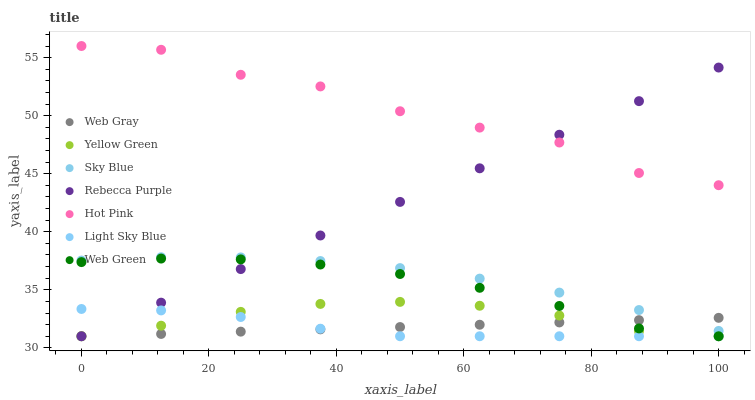Does Light Sky Blue have the minimum area under the curve?
Answer yes or no. Yes. Does Hot Pink have the maximum area under the curve?
Answer yes or no. Yes. Does Yellow Green have the minimum area under the curve?
Answer yes or no. No. Does Yellow Green have the maximum area under the curve?
Answer yes or no. No. Is Web Gray the smoothest?
Answer yes or no. Yes. Is Hot Pink the roughest?
Answer yes or no. Yes. Is Yellow Green the smoothest?
Answer yes or no. No. Is Yellow Green the roughest?
Answer yes or no. No. Does Web Gray have the lowest value?
Answer yes or no. Yes. Does Hot Pink have the lowest value?
Answer yes or no. No. Does Hot Pink have the highest value?
Answer yes or no. Yes. Does Yellow Green have the highest value?
Answer yes or no. No. Is Light Sky Blue less than Sky Blue?
Answer yes or no. Yes. Is Hot Pink greater than Sky Blue?
Answer yes or no. Yes. Does Rebecca Purple intersect Web Gray?
Answer yes or no. Yes. Is Rebecca Purple less than Web Gray?
Answer yes or no. No. Is Rebecca Purple greater than Web Gray?
Answer yes or no. No. Does Light Sky Blue intersect Sky Blue?
Answer yes or no. No. 